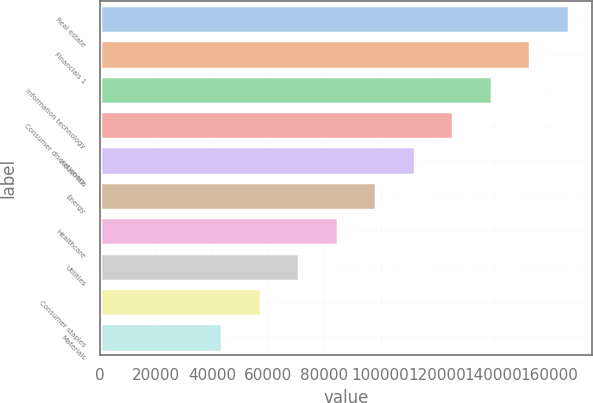Convert chart to OTSL. <chart><loc_0><loc_0><loc_500><loc_500><bar_chart><fcel>Real estate<fcel>Financials 1<fcel>Information technology<fcel>Consumer discretionary<fcel>Industrials<fcel>Energy<fcel>Healthcare<fcel>Utilities<fcel>Consumer staples<fcel>Materials<nl><fcel>166995<fcel>153283<fcel>139571<fcel>125859<fcel>112147<fcel>98434.7<fcel>84722.6<fcel>71010.5<fcel>57298.4<fcel>43586.3<nl></chart> 